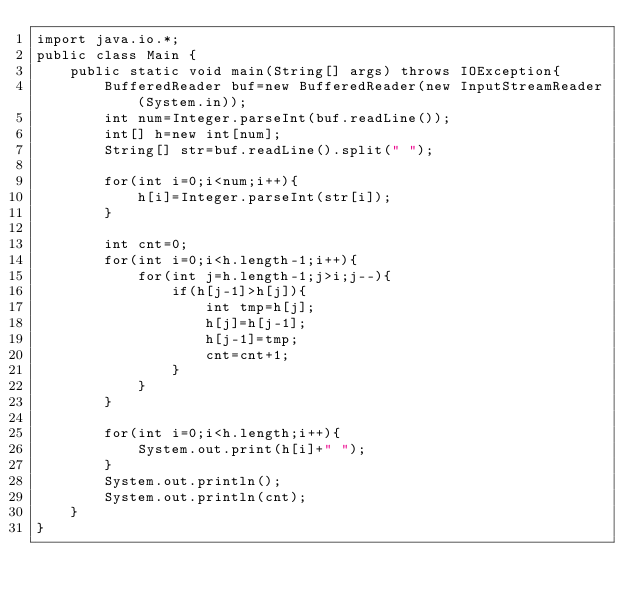Convert code to text. <code><loc_0><loc_0><loc_500><loc_500><_Java_>import java.io.*;
public class Main {
    public static void main(String[] args) throws IOException{
        BufferedReader buf=new BufferedReader(new InputStreamReader(System.in));
        int num=Integer.parseInt(buf.readLine());
        int[] h=new int[num];
        String[] str=buf.readLine().split(" ");
        
        for(int i=0;i<num;i++){
            h[i]=Integer.parseInt(str[i]);
        }
        
        int cnt=0;
        for(int i=0;i<h.length-1;i++){
            for(int j=h.length-1;j>i;j--){
                if(h[j-1]>h[j]){
                    int tmp=h[j];
                    h[j]=h[j-1];
                    h[j-1]=tmp;
                    cnt=cnt+1;
                }
            }
        }
        
        for(int i=0;i<h.length;i++){
            System.out.print(h[i]+" ");
        }
        System.out.println();
        System.out.println(cnt);
    }
}</code> 